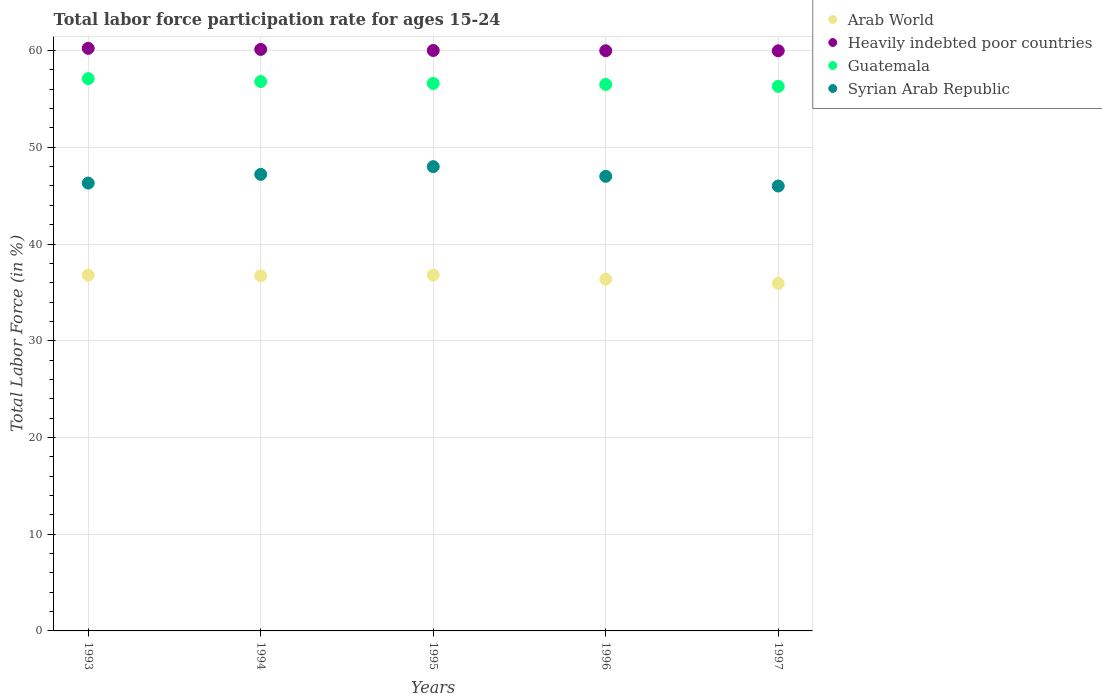Is the number of dotlines equal to the number of legend labels?
Provide a succinct answer. Yes. What is the labor force participation rate in Syrian Arab Republic in 1994?
Keep it short and to the point. 47.2. Across all years, what is the maximum labor force participation rate in Arab World?
Your answer should be very brief. 36.79. Across all years, what is the minimum labor force participation rate in Arab World?
Your answer should be very brief. 35.92. In which year was the labor force participation rate in Syrian Arab Republic minimum?
Your answer should be compact. 1997. What is the total labor force participation rate in Heavily indebted poor countries in the graph?
Your response must be concise. 300.32. What is the difference between the labor force participation rate in Syrian Arab Republic in 1993 and that in 1997?
Your answer should be very brief. 0.3. What is the difference between the labor force participation rate in Guatemala in 1993 and the labor force participation rate in Arab World in 1995?
Your answer should be compact. 20.31. What is the average labor force participation rate in Arab World per year?
Provide a succinct answer. 36.51. In the year 1994, what is the difference between the labor force participation rate in Arab World and labor force participation rate in Syrian Arab Republic?
Your answer should be very brief. -10.49. What is the ratio of the labor force participation rate in Heavily indebted poor countries in 1994 to that in 1996?
Provide a short and direct response. 1. What is the difference between the highest and the second highest labor force participation rate in Guatemala?
Provide a short and direct response. 0.3. What is the difference between the highest and the lowest labor force participation rate in Syrian Arab Republic?
Offer a very short reply. 2. Is it the case that in every year, the sum of the labor force participation rate in Heavily indebted poor countries and labor force participation rate in Guatemala  is greater than the sum of labor force participation rate in Arab World and labor force participation rate in Syrian Arab Republic?
Provide a short and direct response. Yes. Is it the case that in every year, the sum of the labor force participation rate in Arab World and labor force participation rate in Syrian Arab Republic  is greater than the labor force participation rate in Heavily indebted poor countries?
Keep it short and to the point. Yes. Does the labor force participation rate in Syrian Arab Republic monotonically increase over the years?
Ensure brevity in your answer.  No. How many dotlines are there?
Make the answer very short. 4. How many years are there in the graph?
Offer a terse response. 5. What is the difference between two consecutive major ticks on the Y-axis?
Ensure brevity in your answer.  10. Does the graph contain any zero values?
Your answer should be compact. No. Does the graph contain grids?
Your answer should be very brief. Yes. Where does the legend appear in the graph?
Provide a short and direct response. Top right. How many legend labels are there?
Keep it short and to the point. 4. What is the title of the graph?
Make the answer very short. Total labor force participation rate for ages 15-24. What is the label or title of the X-axis?
Give a very brief answer. Years. What is the Total Labor Force (in %) of Arab World in 1993?
Offer a very short reply. 36.78. What is the Total Labor Force (in %) in Heavily indebted poor countries in 1993?
Your answer should be compact. 60.23. What is the Total Labor Force (in %) of Guatemala in 1993?
Provide a short and direct response. 57.1. What is the Total Labor Force (in %) in Syrian Arab Republic in 1993?
Keep it short and to the point. 46.3. What is the Total Labor Force (in %) in Arab World in 1994?
Offer a terse response. 36.71. What is the Total Labor Force (in %) in Heavily indebted poor countries in 1994?
Give a very brief answer. 60.12. What is the Total Labor Force (in %) in Guatemala in 1994?
Provide a succinct answer. 56.8. What is the Total Labor Force (in %) of Syrian Arab Republic in 1994?
Offer a very short reply. 47.2. What is the Total Labor Force (in %) of Arab World in 1995?
Offer a very short reply. 36.79. What is the Total Labor Force (in %) of Heavily indebted poor countries in 1995?
Provide a succinct answer. 60.01. What is the Total Labor Force (in %) of Guatemala in 1995?
Offer a very short reply. 56.6. What is the Total Labor Force (in %) in Syrian Arab Republic in 1995?
Your answer should be very brief. 48. What is the Total Labor Force (in %) in Arab World in 1996?
Your answer should be very brief. 36.37. What is the Total Labor Force (in %) of Heavily indebted poor countries in 1996?
Your answer should be very brief. 59.98. What is the Total Labor Force (in %) in Guatemala in 1996?
Your answer should be very brief. 56.5. What is the Total Labor Force (in %) in Arab World in 1997?
Provide a succinct answer. 35.92. What is the Total Labor Force (in %) of Heavily indebted poor countries in 1997?
Your answer should be compact. 59.98. What is the Total Labor Force (in %) in Guatemala in 1997?
Your answer should be very brief. 56.3. Across all years, what is the maximum Total Labor Force (in %) of Arab World?
Provide a short and direct response. 36.79. Across all years, what is the maximum Total Labor Force (in %) of Heavily indebted poor countries?
Provide a succinct answer. 60.23. Across all years, what is the maximum Total Labor Force (in %) in Guatemala?
Provide a succinct answer. 57.1. Across all years, what is the maximum Total Labor Force (in %) of Syrian Arab Republic?
Your response must be concise. 48. Across all years, what is the minimum Total Labor Force (in %) of Arab World?
Offer a terse response. 35.92. Across all years, what is the minimum Total Labor Force (in %) of Heavily indebted poor countries?
Your answer should be very brief. 59.98. Across all years, what is the minimum Total Labor Force (in %) of Guatemala?
Your answer should be compact. 56.3. What is the total Total Labor Force (in %) in Arab World in the graph?
Your response must be concise. 182.57. What is the total Total Labor Force (in %) in Heavily indebted poor countries in the graph?
Make the answer very short. 300.32. What is the total Total Labor Force (in %) of Guatemala in the graph?
Provide a succinct answer. 283.3. What is the total Total Labor Force (in %) in Syrian Arab Republic in the graph?
Offer a terse response. 234.5. What is the difference between the Total Labor Force (in %) of Arab World in 1993 and that in 1994?
Your answer should be very brief. 0.07. What is the difference between the Total Labor Force (in %) in Heavily indebted poor countries in 1993 and that in 1994?
Make the answer very short. 0.11. What is the difference between the Total Labor Force (in %) of Syrian Arab Republic in 1993 and that in 1994?
Your answer should be very brief. -0.9. What is the difference between the Total Labor Force (in %) in Arab World in 1993 and that in 1995?
Keep it short and to the point. -0.01. What is the difference between the Total Labor Force (in %) in Heavily indebted poor countries in 1993 and that in 1995?
Provide a short and direct response. 0.22. What is the difference between the Total Labor Force (in %) of Guatemala in 1993 and that in 1995?
Offer a very short reply. 0.5. What is the difference between the Total Labor Force (in %) of Syrian Arab Republic in 1993 and that in 1995?
Your answer should be compact. -1.7. What is the difference between the Total Labor Force (in %) in Arab World in 1993 and that in 1996?
Provide a short and direct response. 0.42. What is the difference between the Total Labor Force (in %) in Heavily indebted poor countries in 1993 and that in 1996?
Give a very brief answer. 0.25. What is the difference between the Total Labor Force (in %) of Guatemala in 1993 and that in 1996?
Your response must be concise. 0.6. What is the difference between the Total Labor Force (in %) in Syrian Arab Republic in 1993 and that in 1996?
Your response must be concise. -0.7. What is the difference between the Total Labor Force (in %) of Arab World in 1993 and that in 1997?
Provide a short and direct response. 0.86. What is the difference between the Total Labor Force (in %) of Heavily indebted poor countries in 1993 and that in 1997?
Your response must be concise. 0.26. What is the difference between the Total Labor Force (in %) of Syrian Arab Republic in 1993 and that in 1997?
Provide a short and direct response. 0.3. What is the difference between the Total Labor Force (in %) of Arab World in 1994 and that in 1995?
Your answer should be very brief. -0.08. What is the difference between the Total Labor Force (in %) in Heavily indebted poor countries in 1994 and that in 1995?
Give a very brief answer. 0.11. What is the difference between the Total Labor Force (in %) of Arab World in 1994 and that in 1996?
Offer a terse response. 0.34. What is the difference between the Total Labor Force (in %) of Heavily indebted poor countries in 1994 and that in 1996?
Offer a very short reply. 0.14. What is the difference between the Total Labor Force (in %) in Guatemala in 1994 and that in 1996?
Your answer should be very brief. 0.3. What is the difference between the Total Labor Force (in %) in Arab World in 1994 and that in 1997?
Keep it short and to the point. 0.79. What is the difference between the Total Labor Force (in %) of Heavily indebted poor countries in 1994 and that in 1997?
Ensure brevity in your answer.  0.15. What is the difference between the Total Labor Force (in %) of Guatemala in 1994 and that in 1997?
Offer a terse response. 0.5. What is the difference between the Total Labor Force (in %) in Arab World in 1995 and that in 1996?
Offer a very short reply. 0.42. What is the difference between the Total Labor Force (in %) in Heavily indebted poor countries in 1995 and that in 1996?
Provide a short and direct response. 0.03. What is the difference between the Total Labor Force (in %) of Syrian Arab Republic in 1995 and that in 1996?
Your answer should be compact. 1. What is the difference between the Total Labor Force (in %) of Arab World in 1995 and that in 1997?
Your response must be concise. 0.87. What is the difference between the Total Labor Force (in %) of Heavily indebted poor countries in 1995 and that in 1997?
Make the answer very short. 0.03. What is the difference between the Total Labor Force (in %) of Guatemala in 1995 and that in 1997?
Your response must be concise. 0.3. What is the difference between the Total Labor Force (in %) in Arab World in 1996 and that in 1997?
Give a very brief answer. 0.44. What is the difference between the Total Labor Force (in %) in Heavily indebted poor countries in 1996 and that in 1997?
Provide a short and direct response. 0.01. What is the difference between the Total Labor Force (in %) of Syrian Arab Republic in 1996 and that in 1997?
Your response must be concise. 1. What is the difference between the Total Labor Force (in %) in Arab World in 1993 and the Total Labor Force (in %) in Heavily indebted poor countries in 1994?
Make the answer very short. -23.34. What is the difference between the Total Labor Force (in %) in Arab World in 1993 and the Total Labor Force (in %) in Guatemala in 1994?
Ensure brevity in your answer.  -20.02. What is the difference between the Total Labor Force (in %) of Arab World in 1993 and the Total Labor Force (in %) of Syrian Arab Republic in 1994?
Provide a succinct answer. -10.42. What is the difference between the Total Labor Force (in %) in Heavily indebted poor countries in 1993 and the Total Labor Force (in %) in Guatemala in 1994?
Your answer should be compact. 3.43. What is the difference between the Total Labor Force (in %) in Heavily indebted poor countries in 1993 and the Total Labor Force (in %) in Syrian Arab Republic in 1994?
Your answer should be compact. 13.03. What is the difference between the Total Labor Force (in %) in Arab World in 1993 and the Total Labor Force (in %) in Heavily indebted poor countries in 1995?
Your response must be concise. -23.23. What is the difference between the Total Labor Force (in %) of Arab World in 1993 and the Total Labor Force (in %) of Guatemala in 1995?
Provide a short and direct response. -19.82. What is the difference between the Total Labor Force (in %) of Arab World in 1993 and the Total Labor Force (in %) of Syrian Arab Republic in 1995?
Offer a terse response. -11.22. What is the difference between the Total Labor Force (in %) of Heavily indebted poor countries in 1993 and the Total Labor Force (in %) of Guatemala in 1995?
Keep it short and to the point. 3.63. What is the difference between the Total Labor Force (in %) of Heavily indebted poor countries in 1993 and the Total Labor Force (in %) of Syrian Arab Republic in 1995?
Offer a terse response. 12.23. What is the difference between the Total Labor Force (in %) of Guatemala in 1993 and the Total Labor Force (in %) of Syrian Arab Republic in 1995?
Your response must be concise. 9.1. What is the difference between the Total Labor Force (in %) of Arab World in 1993 and the Total Labor Force (in %) of Heavily indebted poor countries in 1996?
Your answer should be very brief. -23.2. What is the difference between the Total Labor Force (in %) in Arab World in 1993 and the Total Labor Force (in %) in Guatemala in 1996?
Your answer should be very brief. -19.72. What is the difference between the Total Labor Force (in %) of Arab World in 1993 and the Total Labor Force (in %) of Syrian Arab Republic in 1996?
Give a very brief answer. -10.22. What is the difference between the Total Labor Force (in %) of Heavily indebted poor countries in 1993 and the Total Labor Force (in %) of Guatemala in 1996?
Offer a very short reply. 3.73. What is the difference between the Total Labor Force (in %) of Heavily indebted poor countries in 1993 and the Total Labor Force (in %) of Syrian Arab Republic in 1996?
Offer a very short reply. 13.23. What is the difference between the Total Labor Force (in %) of Guatemala in 1993 and the Total Labor Force (in %) of Syrian Arab Republic in 1996?
Your response must be concise. 10.1. What is the difference between the Total Labor Force (in %) of Arab World in 1993 and the Total Labor Force (in %) of Heavily indebted poor countries in 1997?
Your answer should be compact. -23.19. What is the difference between the Total Labor Force (in %) in Arab World in 1993 and the Total Labor Force (in %) in Guatemala in 1997?
Provide a short and direct response. -19.52. What is the difference between the Total Labor Force (in %) in Arab World in 1993 and the Total Labor Force (in %) in Syrian Arab Republic in 1997?
Offer a very short reply. -9.22. What is the difference between the Total Labor Force (in %) of Heavily indebted poor countries in 1993 and the Total Labor Force (in %) of Guatemala in 1997?
Offer a very short reply. 3.93. What is the difference between the Total Labor Force (in %) of Heavily indebted poor countries in 1993 and the Total Labor Force (in %) of Syrian Arab Republic in 1997?
Offer a terse response. 14.23. What is the difference between the Total Labor Force (in %) of Guatemala in 1993 and the Total Labor Force (in %) of Syrian Arab Republic in 1997?
Make the answer very short. 11.1. What is the difference between the Total Labor Force (in %) of Arab World in 1994 and the Total Labor Force (in %) of Heavily indebted poor countries in 1995?
Make the answer very short. -23.3. What is the difference between the Total Labor Force (in %) of Arab World in 1994 and the Total Labor Force (in %) of Guatemala in 1995?
Give a very brief answer. -19.89. What is the difference between the Total Labor Force (in %) in Arab World in 1994 and the Total Labor Force (in %) in Syrian Arab Republic in 1995?
Provide a short and direct response. -11.29. What is the difference between the Total Labor Force (in %) of Heavily indebted poor countries in 1994 and the Total Labor Force (in %) of Guatemala in 1995?
Your response must be concise. 3.52. What is the difference between the Total Labor Force (in %) in Heavily indebted poor countries in 1994 and the Total Labor Force (in %) in Syrian Arab Republic in 1995?
Make the answer very short. 12.12. What is the difference between the Total Labor Force (in %) of Guatemala in 1994 and the Total Labor Force (in %) of Syrian Arab Republic in 1995?
Your response must be concise. 8.8. What is the difference between the Total Labor Force (in %) in Arab World in 1994 and the Total Labor Force (in %) in Heavily indebted poor countries in 1996?
Give a very brief answer. -23.27. What is the difference between the Total Labor Force (in %) in Arab World in 1994 and the Total Labor Force (in %) in Guatemala in 1996?
Your response must be concise. -19.79. What is the difference between the Total Labor Force (in %) of Arab World in 1994 and the Total Labor Force (in %) of Syrian Arab Republic in 1996?
Give a very brief answer. -10.29. What is the difference between the Total Labor Force (in %) of Heavily indebted poor countries in 1994 and the Total Labor Force (in %) of Guatemala in 1996?
Keep it short and to the point. 3.62. What is the difference between the Total Labor Force (in %) in Heavily indebted poor countries in 1994 and the Total Labor Force (in %) in Syrian Arab Republic in 1996?
Make the answer very short. 13.12. What is the difference between the Total Labor Force (in %) in Guatemala in 1994 and the Total Labor Force (in %) in Syrian Arab Republic in 1996?
Your response must be concise. 9.8. What is the difference between the Total Labor Force (in %) of Arab World in 1994 and the Total Labor Force (in %) of Heavily indebted poor countries in 1997?
Make the answer very short. -23.27. What is the difference between the Total Labor Force (in %) in Arab World in 1994 and the Total Labor Force (in %) in Guatemala in 1997?
Keep it short and to the point. -19.59. What is the difference between the Total Labor Force (in %) of Arab World in 1994 and the Total Labor Force (in %) of Syrian Arab Republic in 1997?
Give a very brief answer. -9.29. What is the difference between the Total Labor Force (in %) of Heavily indebted poor countries in 1994 and the Total Labor Force (in %) of Guatemala in 1997?
Keep it short and to the point. 3.82. What is the difference between the Total Labor Force (in %) of Heavily indebted poor countries in 1994 and the Total Labor Force (in %) of Syrian Arab Republic in 1997?
Provide a succinct answer. 14.12. What is the difference between the Total Labor Force (in %) in Arab World in 1995 and the Total Labor Force (in %) in Heavily indebted poor countries in 1996?
Provide a short and direct response. -23.2. What is the difference between the Total Labor Force (in %) in Arab World in 1995 and the Total Labor Force (in %) in Guatemala in 1996?
Offer a very short reply. -19.71. What is the difference between the Total Labor Force (in %) in Arab World in 1995 and the Total Labor Force (in %) in Syrian Arab Republic in 1996?
Offer a terse response. -10.21. What is the difference between the Total Labor Force (in %) of Heavily indebted poor countries in 1995 and the Total Labor Force (in %) of Guatemala in 1996?
Keep it short and to the point. 3.51. What is the difference between the Total Labor Force (in %) in Heavily indebted poor countries in 1995 and the Total Labor Force (in %) in Syrian Arab Republic in 1996?
Make the answer very short. 13.01. What is the difference between the Total Labor Force (in %) of Arab World in 1995 and the Total Labor Force (in %) of Heavily indebted poor countries in 1997?
Make the answer very short. -23.19. What is the difference between the Total Labor Force (in %) in Arab World in 1995 and the Total Labor Force (in %) in Guatemala in 1997?
Provide a short and direct response. -19.51. What is the difference between the Total Labor Force (in %) of Arab World in 1995 and the Total Labor Force (in %) of Syrian Arab Republic in 1997?
Offer a very short reply. -9.21. What is the difference between the Total Labor Force (in %) in Heavily indebted poor countries in 1995 and the Total Labor Force (in %) in Guatemala in 1997?
Make the answer very short. 3.71. What is the difference between the Total Labor Force (in %) of Heavily indebted poor countries in 1995 and the Total Labor Force (in %) of Syrian Arab Republic in 1997?
Keep it short and to the point. 14.01. What is the difference between the Total Labor Force (in %) of Arab World in 1996 and the Total Labor Force (in %) of Heavily indebted poor countries in 1997?
Provide a succinct answer. -23.61. What is the difference between the Total Labor Force (in %) of Arab World in 1996 and the Total Labor Force (in %) of Guatemala in 1997?
Provide a short and direct response. -19.93. What is the difference between the Total Labor Force (in %) of Arab World in 1996 and the Total Labor Force (in %) of Syrian Arab Republic in 1997?
Your answer should be compact. -9.63. What is the difference between the Total Labor Force (in %) of Heavily indebted poor countries in 1996 and the Total Labor Force (in %) of Guatemala in 1997?
Your answer should be very brief. 3.68. What is the difference between the Total Labor Force (in %) of Heavily indebted poor countries in 1996 and the Total Labor Force (in %) of Syrian Arab Republic in 1997?
Offer a very short reply. 13.98. What is the difference between the Total Labor Force (in %) in Guatemala in 1996 and the Total Labor Force (in %) in Syrian Arab Republic in 1997?
Offer a terse response. 10.5. What is the average Total Labor Force (in %) of Arab World per year?
Offer a terse response. 36.51. What is the average Total Labor Force (in %) in Heavily indebted poor countries per year?
Make the answer very short. 60.06. What is the average Total Labor Force (in %) in Guatemala per year?
Provide a short and direct response. 56.66. What is the average Total Labor Force (in %) of Syrian Arab Republic per year?
Offer a very short reply. 46.9. In the year 1993, what is the difference between the Total Labor Force (in %) in Arab World and Total Labor Force (in %) in Heavily indebted poor countries?
Offer a very short reply. -23.45. In the year 1993, what is the difference between the Total Labor Force (in %) in Arab World and Total Labor Force (in %) in Guatemala?
Provide a short and direct response. -20.32. In the year 1993, what is the difference between the Total Labor Force (in %) in Arab World and Total Labor Force (in %) in Syrian Arab Republic?
Ensure brevity in your answer.  -9.52. In the year 1993, what is the difference between the Total Labor Force (in %) of Heavily indebted poor countries and Total Labor Force (in %) of Guatemala?
Provide a short and direct response. 3.13. In the year 1993, what is the difference between the Total Labor Force (in %) of Heavily indebted poor countries and Total Labor Force (in %) of Syrian Arab Republic?
Your answer should be compact. 13.93. In the year 1993, what is the difference between the Total Labor Force (in %) of Guatemala and Total Labor Force (in %) of Syrian Arab Republic?
Your answer should be very brief. 10.8. In the year 1994, what is the difference between the Total Labor Force (in %) of Arab World and Total Labor Force (in %) of Heavily indebted poor countries?
Keep it short and to the point. -23.41. In the year 1994, what is the difference between the Total Labor Force (in %) of Arab World and Total Labor Force (in %) of Guatemala?
Provide a succinct answer. -20.09. In the year 1994, what is the difference between the Total Labor Force (in %) of Arab World and Total Labor Force (in %) of Syrian Arab Republic?
Offer a terse response. -10.49. In the year 1994, what is the difference between the Total Labor Force (in %) of Heavily indebted poor countries and Total Labor Force (in %) of Guatemala?
Keep it short and to the point. 3.32. In the year 1994, what is the difference between the Total Labor Force (in %) in Heavily indebted poor countries and Total Labor Force (in %) in Syrian Arab Republic?
Provide a short and direct response. 12.92. In the year 1995, what is the difference between the Total Labor Force (in %) of Arab World and Total Labor Force (in %) of Heavily indebted poor countries?
Make the answer very short. -23.22. In the year 1995, what is the difference between the Total Labor Force (in %) of Arab World and Total Labor Force (in %) of Guatemala?
Make the answer very short. -19.81. In the year 1995, what is the difference between the Total Labor Force (in %) of Arab World and Total Labor Force (in %) of Syrian Arab Republic?
Your answer should be compact. -11.21. In the year 1995, what is the difference between the Total Labor Force (in %) of Heavily indebted poor countries and Total Labor Force (in %) of Guatemala?
Offer a very short reply. 3.41. In the year 1995, what is the difference between the Total Labor Force (in %) of Heavily indebted poor countries and Total Labor Force (in %) of Syrian Arab Republic?
Your answer should be compact. 12.01. In the year 1996, what is the difference between the Total Labor Force (in %) of Arab World and Total Labor Force (in %) of Heavily indebted poor countries?
Make the answer very short. -23.62. In the year 1996, what is the difference between the Total Labor Force (in %) of Arab World and Total Labor Force (in %) of Guatemala?
Offer a very short reply. -20.13. In the year 1996, what is the difference between the Total Labor Force (in %) in Arab World and Total Labor Force (in %) in Syrian Arab Republic?
Keep it short and to the point. -10.63. In the year 1996, what is the difference between the Total Labor Force (in %) of Heavily indebted poor countries and Total Labor Force (in %) of Guatemala?
Provide a short and direct response. 3.48. In the year 1996, what is the difference between the Total Labor Force (in %) of Heavily indebted poor countries and Total Labor Force (in %) of Syrian Arab Republic?
Provide a succinct answer. 12.98. In the year 1997, what is the difference between the Total Labor Force (in %) of Arab World and Total Labor Force (in %) of Heavily indebted poor countries?
Keep it short and to the point. -24.05. In the year 1997, what is the difference between the Total Labor Force (in %) in Arab World and Total Labor Force (in %) in Guatemala?
Make the answer very short. -20.38. In the year 1997, what is the difference between the Total Labor Force (in %) in Arab World and Total Labor Force (in %) in Syrian Arab Republic?
Your answer should be compact. -10.08. In the year 1997, what is the difference between the Total Labor Force (in %) of Heavily indebted poor countries and Total Labor Force (in %) of Guatemala?
Offer a very short reply. 3.68. In the year 1997, what is the difference between the Total Labor Force (in %) in Heavily indebted poor countries and Total Labor Force (in %) in Syrian Arab Republic?
Provide a short and direct response. 13.98. What is the ratio of the Total Labor Force (in %) in Arab World in 1993 to that in 1994?
Offer a terse response. 1. What is the ratio of the Total Labor Force (in %) in Syrian Arab Republic in 1993 to that in 1994?
Offer a very short reply. 0.98. What is the ratio of the Total Labor Force (in %) in Arab World in 1993 to that in 1995?
Your response must be concise. 1. What is the ratio of the Total Labor Force (in %) in Heavily indebted poor countries in 1993 to that in 1995?
Make the answer very short. 1. What is the ratio of the Total Labor Force (in %) of Guatemala in 1993 to that in 1995?
Make the answer very short. 1.01. What is the ratio of the Total Labor Force (in %) in Syrian Arab Republic in 1993 to that in 1995?
Make the answer very short. 0.96. What is the ratio of the Total Labor Force (in %) of Arab World in 1993 to that in 1996?
Provide a short and direct response. 1.01. What is the ratio of the Total Labor Force (in %) of Heavily indebted poor countries in 1993 to that in 1996?
Provide a succinct answer. 1. What is the ratio of the Total Labor Force (in %) of Guatemala in 1993 to that in 1996?
Provide a short and direct response. 1.01. What is the ratio of the Total Labor Force (in %) in Syrian Arab Republic in 1993 to that in 1996?
Offer a terse response. 0.99. What is the ratio of the Total Labor Force (in %) in Heavily indebted poor countries in 1993 to that in 1997?
Provide a short and direct response. 1. What is the ratio of the Total Labor Force (in %) of Guatemala in 1993 to that in 1997?
Offer a terse response. 1.01. What is the ratio of the Total Labor Force (in %) in Arab World in 1994 to that in 1995?
Keep it short and to the point. 1. What is the ratio of the Total Labor Force (in %) in Guatemala in 1994 to that in 1995?
Your response must be concise. 1. What is the ratio of the Total Labor Force (in %) of Syrian Arab Republic in 1994 to that in 1995?
Give a very brief answer. 0.98. What is the ratio of the Total Labor Force (in %) of Arab World in 1994 to that in 1996?
Keep it short and to the point. 1.01. What is the ratio of the Total Labor Force (in %) in Heavily indebted poor countries in 1994 to that in 1996?
Provide a short and direct response. 1. What is the ratio of the Total Labor Force (in %) in Guatemala in 1994 to that in 1996?
Offer a very short reply. 1.01. What is the ratio of the Total Labor Force (in %) in Arab World in 1994 to that in 1997?
Make the answer very short. 1.02. What is the ratio of the Total Labor Force (in %) in Heavily indebted poor countries in 1994 to that in 1997?
Offer a terse response. 1. What is the ratio of the Total Labor Force (in %) of Guatemala in 1994 to that in 1997?
Keep it short and to the point. 1.01. What is the ratio of the Total Labor Force (in %) of Syrian Arab Republic in 1994 to that in 1997?
Offer a terse response. 1.03. What is the ratio of the Total Labor Force (in %) of Arab World in 1995 to that in 1996?
Your answer should be compact. 1.01. What is the ratio of the Total Labor Force (in %) in Syrian Arab Republic in 1995 to that in 1996?
Offer a terse response. 1.02. What is the ratio of the Total Labor Force (in %) in Arab World in 1995 to that in 1997?
Offer a terse response. 1.02. What is the ratio of the Total Labor Force (in %) of Heavily indebted poor countries in 1995 to that in 1997?
Your answer should be compact. 1. What is the ratio of the Total Labor Force (in %) in Syrian Arab Republic in 1995 to that in 1997?
Ensure brevity in your answer.  1.04. What is the ratio of the Total Labor Force (in %) of Arab World in 1996 to that in 1997?
Offer a very short reply. 1.01. What is the ratio of the Total Labor Force (in %) in Heavily indebted poor countries in 1996 to that in 1997?
Make the answer very short. 1. What is the ratio of the Total Labor Force (in %) of Guatemala in 1996 to that in 1997?
Provide a short and direct response. 1. What is the ratio of the Total Labor Force (in %) in Syrian Arab Republic in 1996 to that in 1997?
Provide a succinct answer. 1.02. What is the difference between the highest and the second highest Total Labor Force (in %) of Arab World?
Offer a terse response. 0.01. What is the difference between the highest and the second highest Total Labor Force (in %) in Heavily indebted poor countries?
Ensure brevity in your answer.  0.11. What is the difference between the highest and the lowest Total Labor Force (in %) in Arab World?
Provide a succinct answer. 0.87. What is the difference between the highest and the lowest Total Labor Force (in %) of Heavily indebted poor countries?
Offer a terse response. 0.26. What is the difference between the highest and the lowest Total Labor Force (in %) in Guatemala?
Offer a terse response. 0.8. What is the difference between the highest and the lowest Total Labor Force (in %) in Syrian Arab Republic?
Your answer should be very brief. 2. 